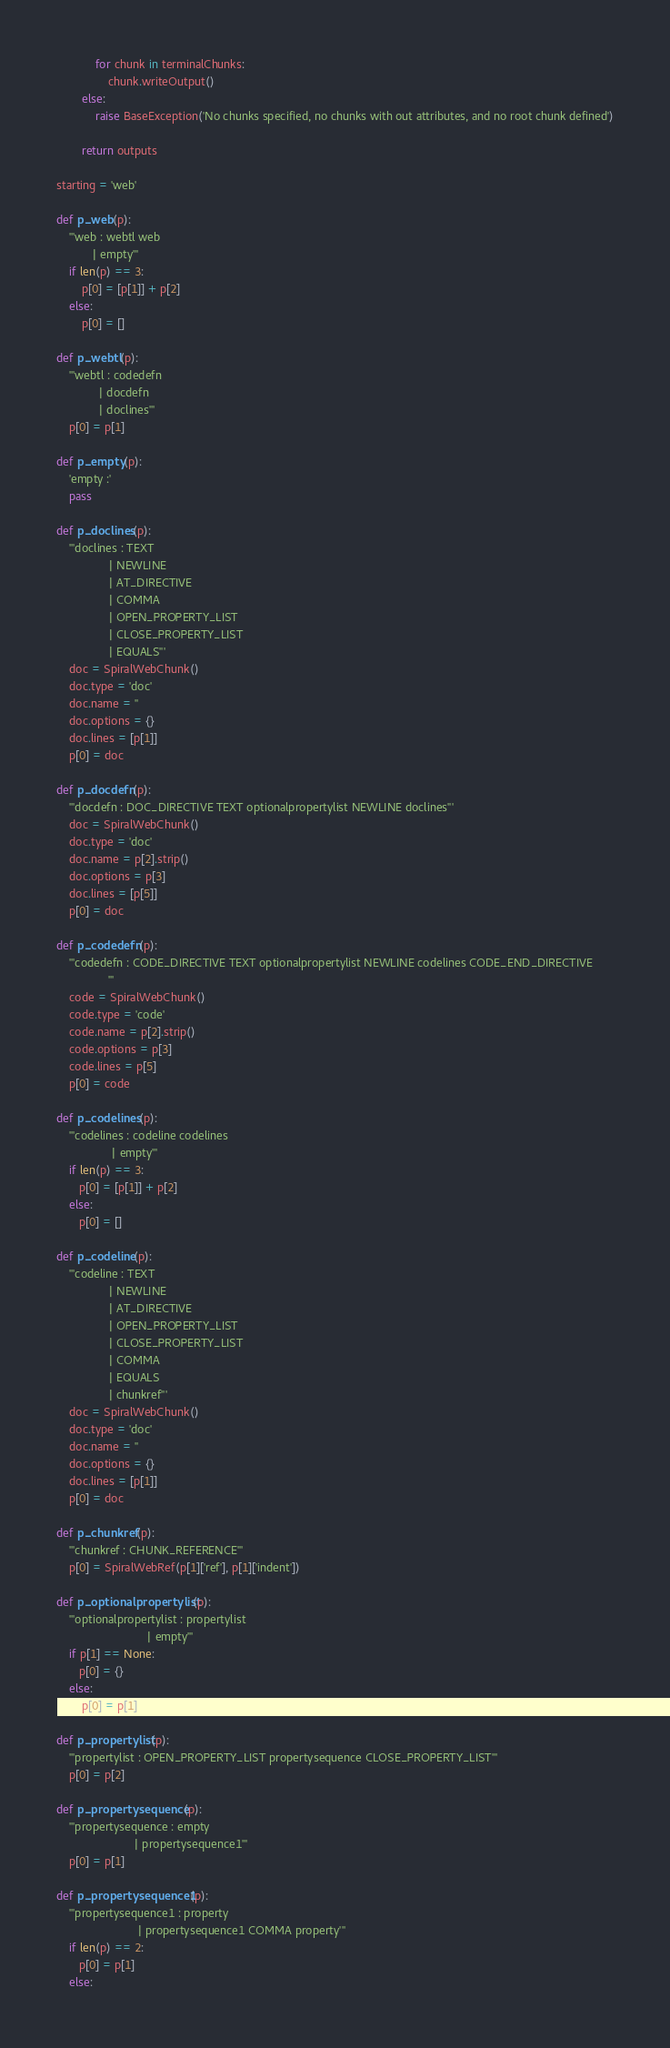Convert code to text. <code><loc_0><loc_0><loc_500><loc_500><_Python_>            for chunk in terminalChunks:
                chunk.writeOutput()
        else:
            raise BaseException('No chunks specified, no chunks with out attributes, and no root chunk defined')
            
        return outputs

starting = 'web'

def p_web(p):
    '''web : webtl web
           | empty'''
    if len(p) == 3:
        p[0] = [p[1]] + p[2]
    else:
        p[0] = []

def p_webtl(p):
    '''webtl : codedefn
             | docdefn
             | doclines'''
    p[0] = p[1]

def p_empty(p):
    'empty :'
    pass

def p_doclines(p):
    '''doclines : TEXT
                | NEWLINE
                | AT_DIRECTIVE
                | COMMA
                | OPEN_PROPERTY_LIST
                | CLOSE_PROPERTY_LIST
                | EQUALS'''
    doc = SpiralWebChunk()
    doc.type = 'doc'
    doc.name = ''
    doc.options = {}
    doc.lines = [p[1]]
    p[0] = doc

def p_docdefn(p):
    '''docdefn : DOC_DIRECTIVE TEXT optionalpropertylist NEWLINE doclines'''
    doc = SpiralWebChunk()
    doc.type = 'doc'
    doc.name = p[2].strip()
    doc.options = p[3]
    doc.lines = [p[5]]
    p[0] = doc

def p_codedefn(p):
    '''codedefn : CODE_DIRECTIVE TEXT optionalpropertylist NEWLINE codelines CODE_END_DIRECTIVE
                '''
    code = SpiralWebChunk()
    code.type = 'code'
    code.name = p[2].strip()
    code.options = p[3]
    code.lines = p[5]
    p[0] = code

def p_codelines(p):
    '''codelines : codeline codelines
                 | empty'''
    if len(p) == 3:
       p[0] = [p[1]] + p[2]
    else:
       p[0] = []

def p_codeline(p):
    '''codeline : TEXT 
                | NEWLINE
                | AT_DIRECTIVE
                | OPEN_PROPERTY_LIST
                | CLOSE_PROPERTY_LIST
                | COMMA
                | EQUALS
                | chunkref'''
    doc = SpiralWebChunk()
    doc.type = 'doc'
    doc.name = ''
    doc.options = {}
    doc.lines = [p[1]]
    p[0] = doc

def p_chunkref(p):
    '''chunkref : CHUNK_REFERENCE'''
    p[0] = SpiralWebRef(p[1]['ref'], p[1]['indent'])

def p_optionalpropertylist(p):
    '''optionalpropertylist : propertylist 
                            | empty'''
    if p[1] == None:
       p[0] = {}
    else:
        p[0] = p[1]

def p_propertylist(p):
    '''propertylist : OPEN_PROPERTY_LIST propertysequence CLOSE_PROPERTY_LIST'''
    p[0] = p[2]

def p_propertysequence(p):
    '''propertysequence : empty 
                        | propertysequence1'''
    p[0] = p[1]

def p_propertysequence1(p):
    '''propertysequence1 : property 
                         | propertysequence1 COMMA property'''
    if len(p) == 2:
       p[0] = p[1]
    else:</code> 